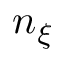Convert formula to latex. <formula><loc_0><loc_0><loc_500><loc_500>n _ { \xi }</formula> 